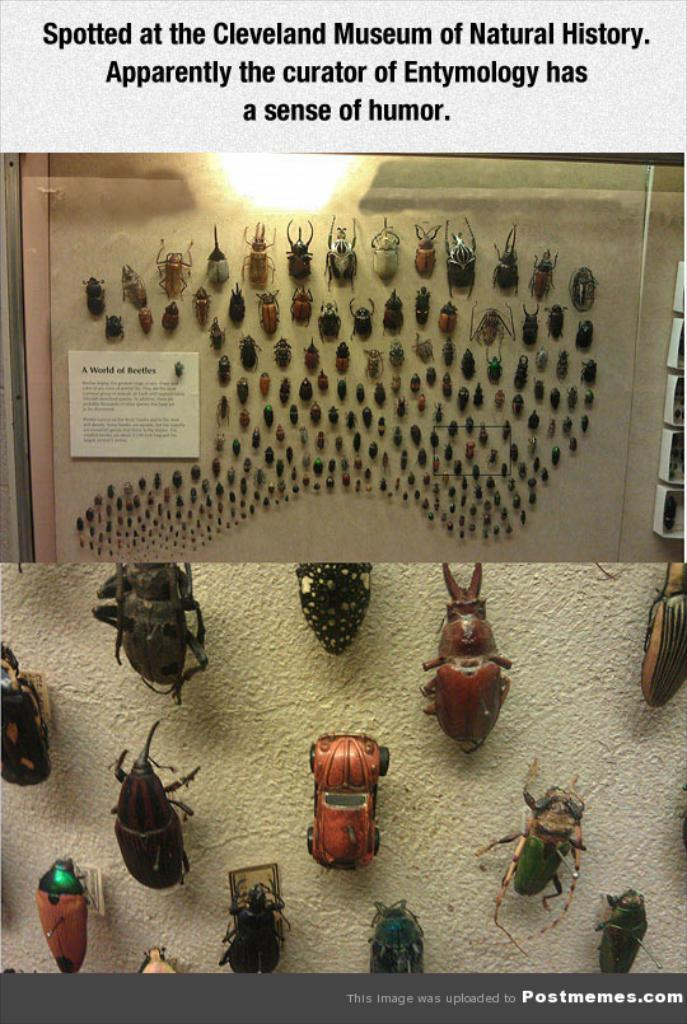What is the main subject of the poster in the image? The poster contains images of bugs and insects. What else can be found on the poster besides the images? There is text on the poster. What type of collar is visible on the bugs in the image? There are no collars present on the bugs in the image, as they are depicted in their natural state. 